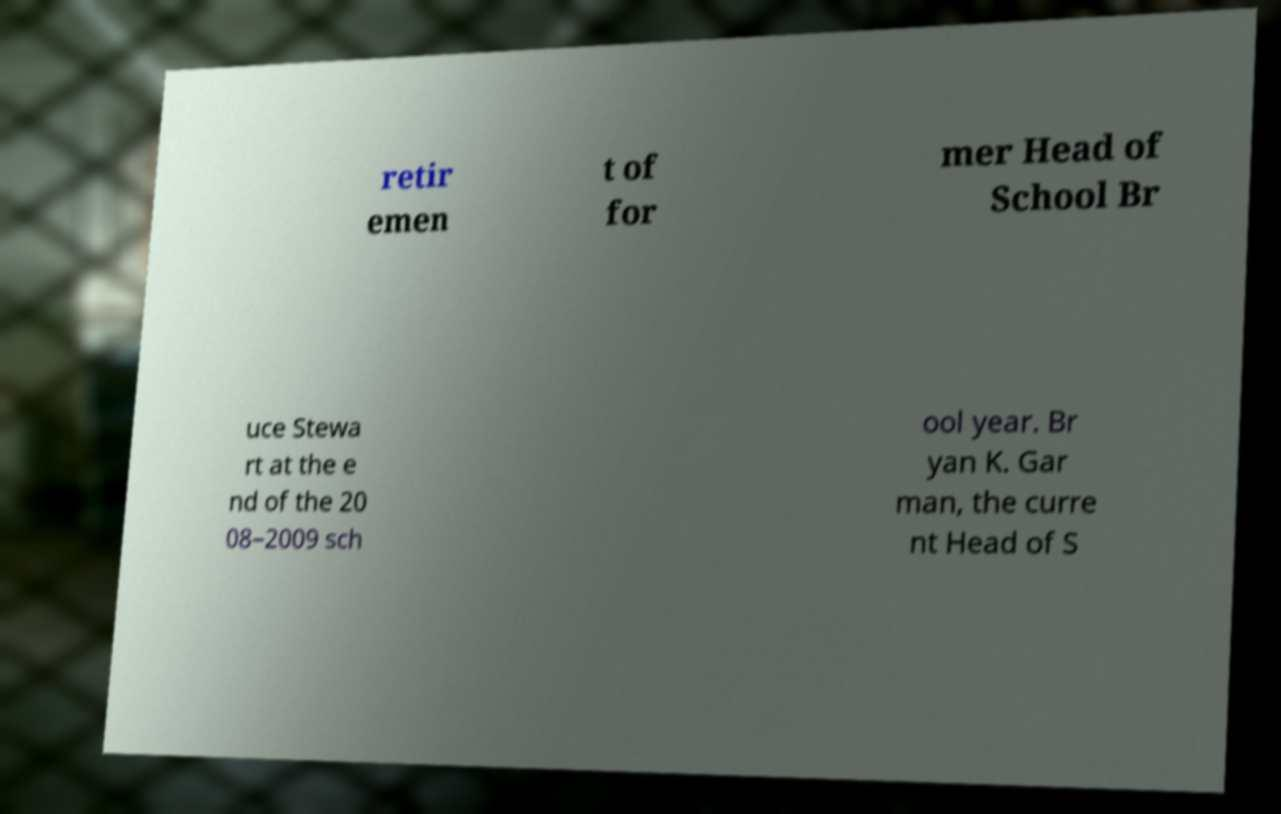Could you extract and type out the text from this image? retir emen t of for mer Head of School Br uce Stewa rt at the e nd of the 20 08–2009 sch ool year. Br yan K. Gar man, the curre nt Head of S 